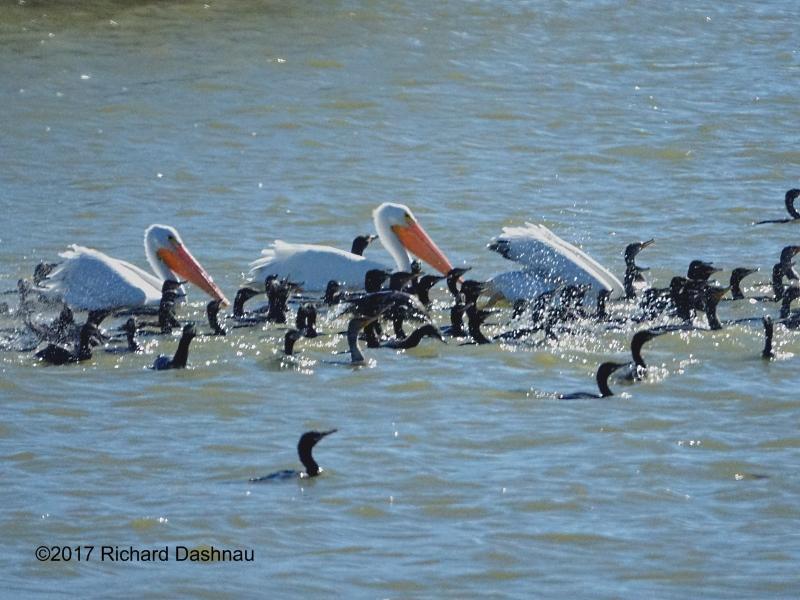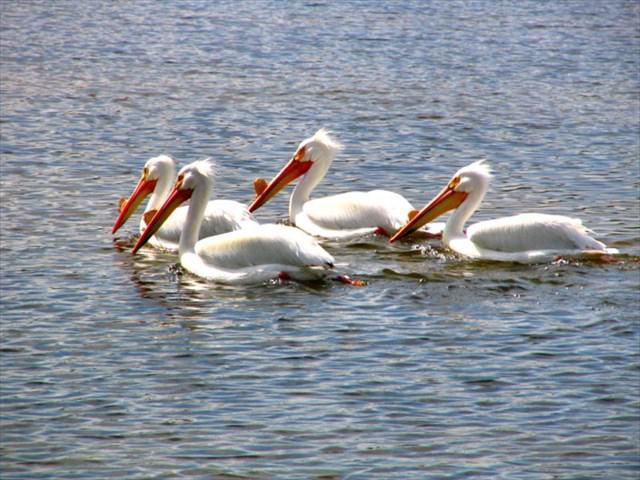The first image is the image on the left, the second image is the image on the right. Assess this claim about the two images: "All of the pelicans are swimming.". Correct or not? Answer yes or no. Yes. 